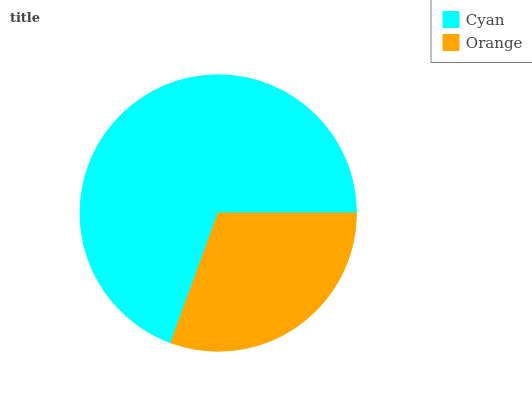Is Orange the minimum?
Answer yes or no. Yes. Is Cyan the maximum?
Answer yes or no. Yes. Is Orange the maximum?
Answer yes or no. No. Is Cyan greater than Orange?
Answer yes or no. Yes. Is Orange less than Cyan?
Answer yes or no. Yes. Is Orange greater than Cyan?
Answer yes or no. No. Is Cyan less than Orange?
Answer yes or no. No. Is Cyan the high median?
Answer yes or no. Yes. Is Orange the low median?
Answer yes or no. Yes. Is Orange the high median?
Answer yes or no. No. Is Cyan the low median?
Answer yes or no. No. 